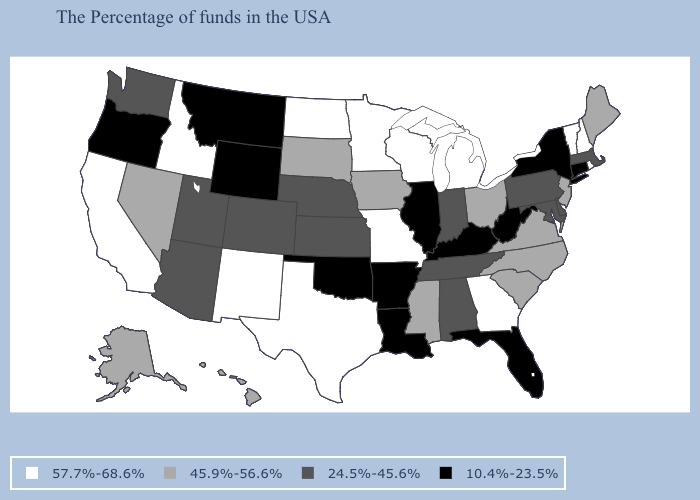Is the legend a continuous bar?
Write a very short answer. No. What is the highest value in the Northeast ?
Be succinct. 57.7%-68.6%. Does Texas have the same value as Kentucky?
Be succinct. No. How many symbols are there in the legend?
Be succinct. 4. Name the states that have a value in the range 24.5%-45.6%?
Give a very brief answer. Massachusetts, Delaware, Maryland, Pennsylvania, Indiana, Alabama, Tennessee, Kansas, Nebraska, Colorado, Utah, Arizona, Washington. Name the states that have a value in the range 45.9%-56.6%?
Write a very short answer. Maine, New Jersey, Virginia, North Carolina, South Carolina, Ohio, Mississippi, Iowa, South Dakota, Nevada, Alaska, Hawaii. Which states have the lowest value in the West?
Answer briefly. Wyoming, Montana, Oregon. What is the lowest value in the USA?
Write a very short answer. 10.4%-23.5%. Name the states that have a value in the range 24.5%-45.6%?
Concise answer only. Massachusetts, Delaware, Maryland, Pennsylvania, Indiana, Alabama, Tennessee, Kansas, Nebraska, Colorado, Utah, Arizona, Washington. Among the states that border New York , which have the highest value?
Keep it brief. Vermont. What is the value of Montana?
Keep it brief. 10.4%-23.5%. Name the states that have a value in the range 10.4%-23.5%?
Keep it brief. Connecticut, New York, West Virginia, Florida, Kentucky, Illinois, Louisiana, Arkansas, Oklahoma, Wyoming, Montana, Oregon. Which states hav the highest value in the MidWest?
Give a very brief answer. Michigan, Wisconsin, Missouri, Minnesota, North Dakota. Name the states that have a value in the range 57.7%-68.6%?
Short answer required. Rhode Island, New Hampshire, Vermont, Georgia, Michigan, Wisconsin, Missouri, Minnesota, Texas, North Dakota, New Mexico, Idaho, California. Does Minnesota have the highest value in the USA?
Answer briefly. Yes. 